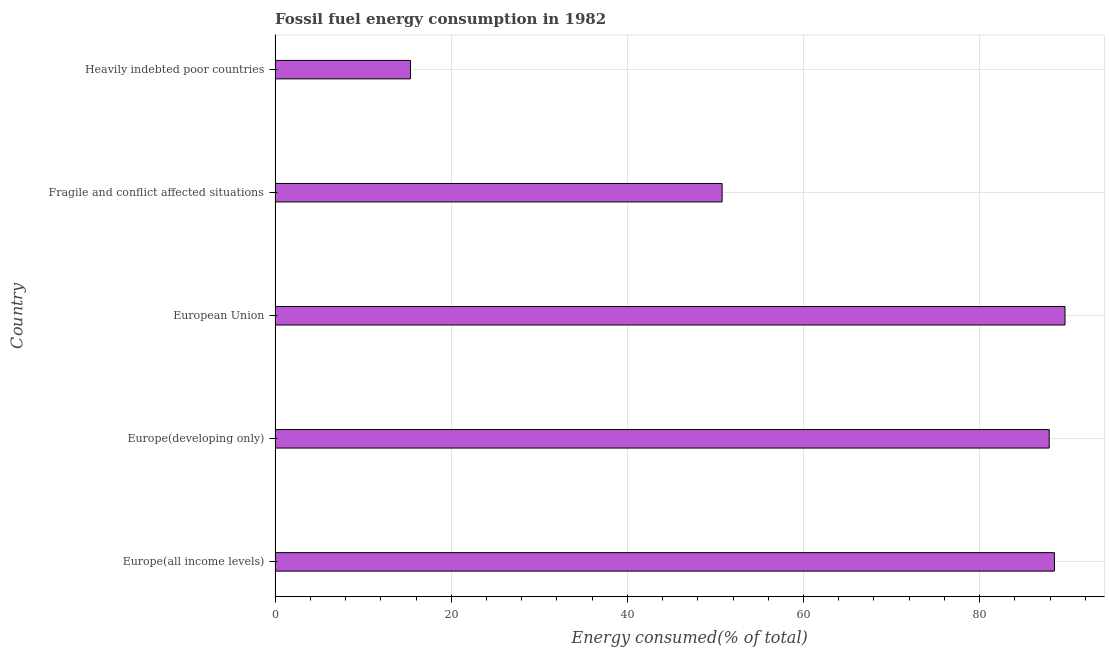Does the graph contain any zero values?
Your response must be concise. No. What is the title of the graph?
Your answer should be compact. Fossil fuel energy consumption in 1982. What is the label or title of the X-axis?
Keep it short and to the point. Energy consumed(% of total). What is the fossil fuel energy consumption in Fragile and conflict affected situations?
Provide a short and direct response. 50.76. Across all countries, what is the maximum fossil fuel energy consumption?
Your answer should be very brief. 89.69. Across all countries, what is the minimum fossil fuel energy consumption?
Give a very brief answer. 15.37. In which country was the fossil fuel energy consumption maximum?
Your answer should be very brief. European Union. In which country was the fossil fuel energy consumption minimum?
Give a very brief answer. Heavily indebted poor countries. What is the sum of the fossil fuel energy consumption?
Keep it short and to the point. 332.2. What is the difference between the fossil fuel energy consumption in Fragile and conflict affected situations and Heavily indebted poor countries?
Offer a very short reply. 35.39. What is the average fossil fuel energy consumption per country?
Give a very brief answer. 66.44. What is the median fossil fuel energy consumption?
Offer a very short reply. 87.9. In how many countries, is the fossil fuel energy consumption greater than 52 %?
Your answer should be compact. 3. What is the ratio of the fossil fuel energy consumption in Europe(all income levels) to that in European Union?
Make the answer very short. 0.99. Is the fossil fuel energy consumption in Europe(all income levels) less than that in Fragile and conflict affected situations?
Keep it short and to the point. No. What is the difference between the highest and the second highest fossil fuel energy consumption?
Ensure brevity in your answer.  1.2. Is the sum of the fossil fuel energy consumption in Fragile and conflict affected situations and Heavily indebted poor countries greater than the maximum fossil fuel energy consumption across all countries?
Keep it short and to the point. No. What is the difference between the highest and the lowest fossil fuel energy consumption?
Your answer should be very brief. 74.32. In how many countries, is the fossil fuel energy consumption greater than the average fossil fuel energy consumption taken over all countries?
Offer a terse response. 3. How many bars are there?
Ensure brevity in your answer.  5. Are the values on the major ticks of X-axis written in scientific E-notation?
Keep it short and to the point. No. What is the Energy consumed(% of total) in Europe(all income levels)?
Keep it short and to the point. 88.49. What is the Energy consumed(% of total) in Europe(developing only)?
Offer a terse response. 87.9. What is the Energy consumed(% of total) in European Union?
Make the answer very short. 89.69. What is the Energy consumed(% of total) in Fragile and conflict affected situations?
Your response must be concise. 50.76. What is the Energy consumed(% of total) in Heavily indebted poor countries?
Your response must be concise. 15.37. What is the difference between the Energy consumed(% of total) in Europe(all income levels) and Europe(developing only)?
Your response must be concise. 0.59. What is the difference between the Energy consumed(% of total) in Europe(all income levels) and European Union?
Provide a short and direct response. -1.2. What is the difference between the Energy consumed(% of total) in Europe(all income levels) and Fragile and conflict affected situations?
Offer a very short reply. 37.73. What is the difference between the Energy consumed(% of total) in Europe(all income levels) and Heavily indebted poor countries?
Give a very brief answer. 73.12. What is the difference between the Energy consumed(% of total) in Europe(developing only) and European Union?
Offer a terse response. -1.79. What is the difference between the Energy consumed(% of total) in Europe(developing only) and Fragile and conflict affected situations?
Keep it short and to the point. 37.14. What is the difference between the Energy consumed(% of total) in Europe(developing only) and Heavily indebted poor countries?
Give a very brief answer. 72.53. What is the difference between the Energy consumed(% of total) in European Union and Fragile and conflict affected situations?
Make the answer very short. 38.93. What is the difference between the Energy consumed(% of total) in European Union and Heavily indebted poor countries?
Offer a terse response. 74.32. What is the difference between the Energy consumed(% of total) in Fragile and conflict affected situations and Heavily indebted poor countries?
Offer a very short reply. 35.39. What is the ratio of the Energy consumed(% of total) in Europe(all income levels) to that in Fragile and conflict affected situations?
Offer a terse response. 1.74. What is the ratio of the Energy consumed(% of total) in Europe(all income levels) to that in Heavily indebted poor countries?
Offer a terse response. 5.76. What is the ratio of the Energy consumed(% of total) in Europe(developing only) to that in Fragile and conflict affected situations?
Give a very brief answer. 1.73. What is the ratio of the Energy consumed(% of total) in Europe(developing only) to that in Heavily indebted poor countries?
Give a very brief answer. 5.72. What is the ratio of the Energy consumed(% of total) in European Union to that in Fragile and conflict affected situations?
Offer a very short reply. 1.77. What is the ratio of the Energy consumed(% of total) in European Union to that in Heavily indebted poor countries?
Your answer should be very brief. 5.84. What is the ratio of the Energy consumed(% of total) in Fragile and conflict affected situations to that in Heavily indebted poor countries?
Offer a very short reply. 3.3. 